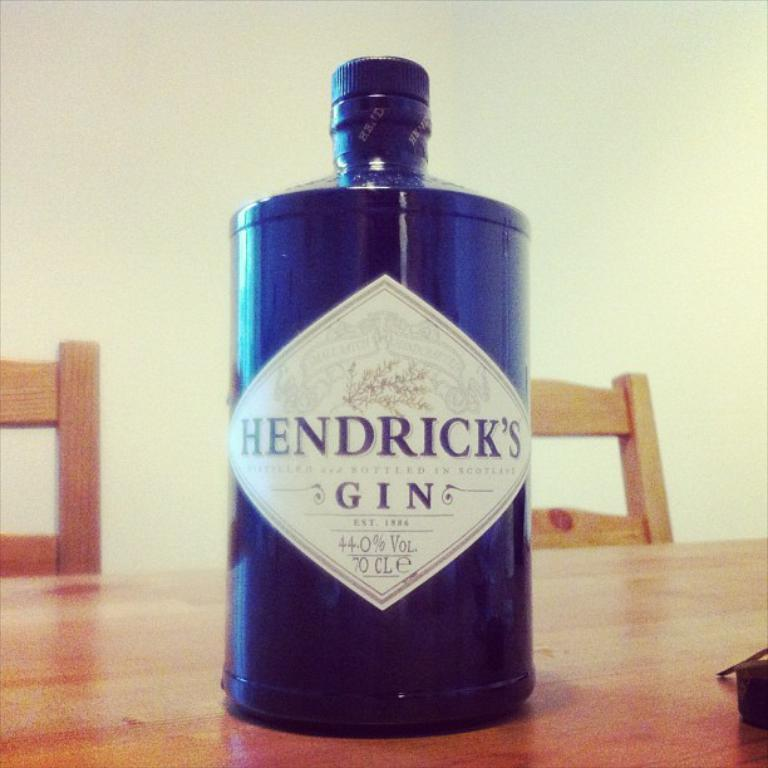<image>
Write a terse but informative summary of the picture. A blue bottle of Hendrick's Gin is on a table. 